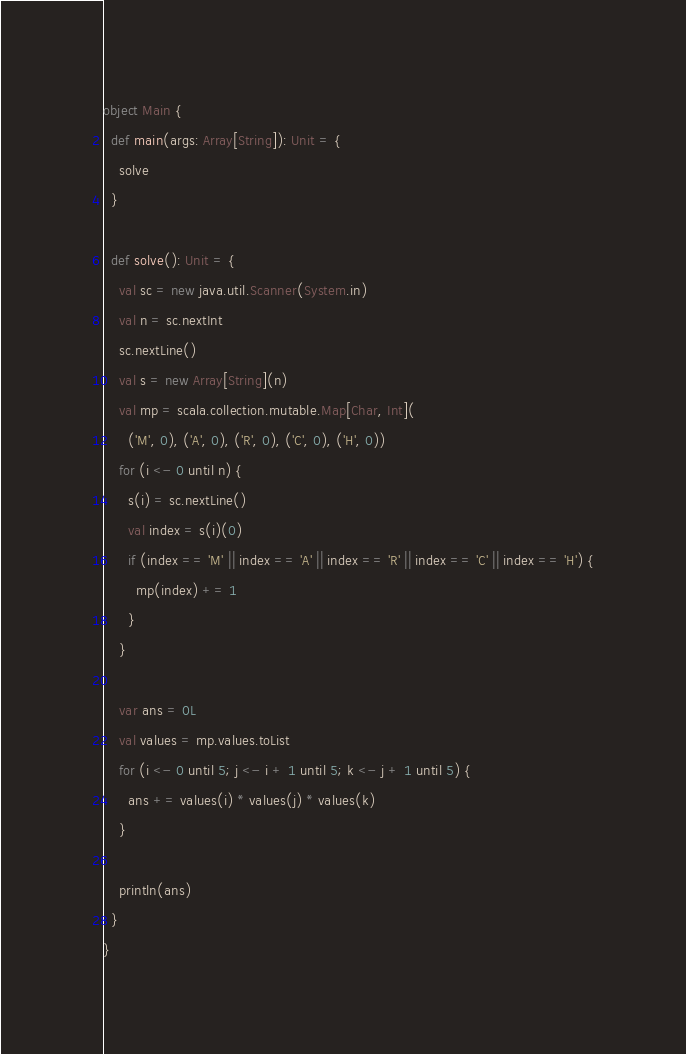<code> <loc_0><loc_0><loc_500><loc_500><_Scala_>object Main {
  def main(args: Array[String]): Unit = {
    solve
  }

  def solve(): Unit = {
    val sc = new java.util.Scanner(System.in)
    val n = sc.nextInt
    sc.nextLine()
    val s = new Array[String](n)
    val mp = scala.collection.mutable.Map[Char, Int](
      ('M', 0), ('A', 0), ('R', 0), ('C', 0), ('H', 0))
    for (i <- 0 until n) {
      s(i) = sc.nextLine()
      val index = s(i)(0)
      if (index == 'M' || index == 'A' || index == 'R' || index == 'C' || index == 'H') {
        mp(index) += 1
      }
    }

    var ans = 0L
    val values = mp.values.toList
    for (i <- 0 until 5; j <- i + 1 until 5; k <- j + 1 until 5) {
      ans += values(i) * values(j) * values(k)
    }

    println(ans)
  }
}
</code> 